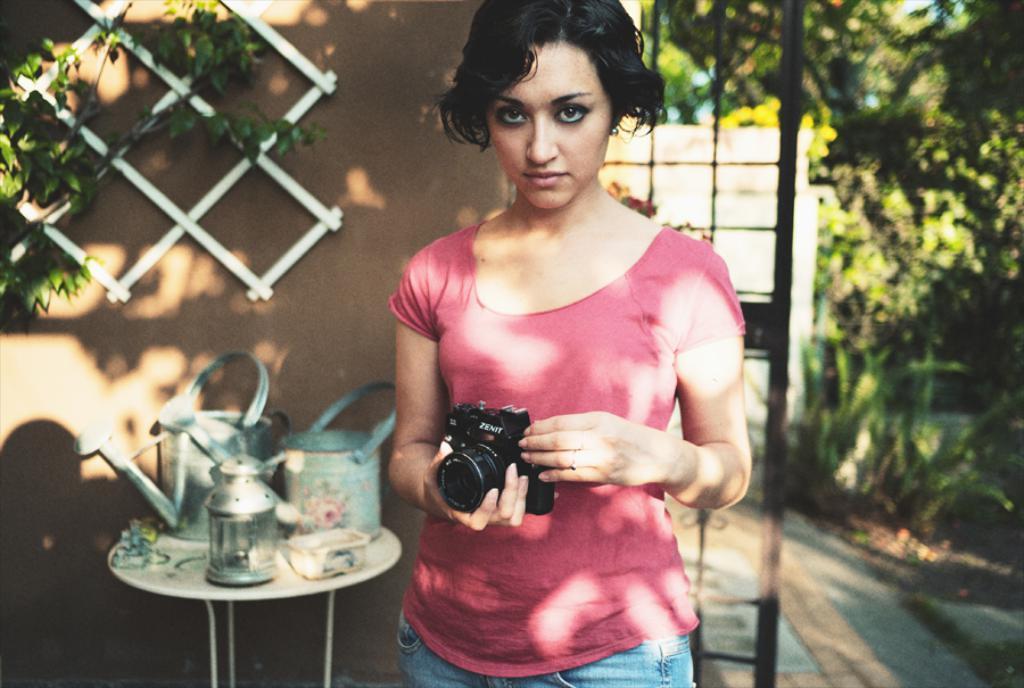Describe this image in one or two sentences. In this image i can see a lady person wearing pink color dress and holding camera in her hands at the left side of the image there are some objects on top of the table and at the background of the image there is a wall and trees. 